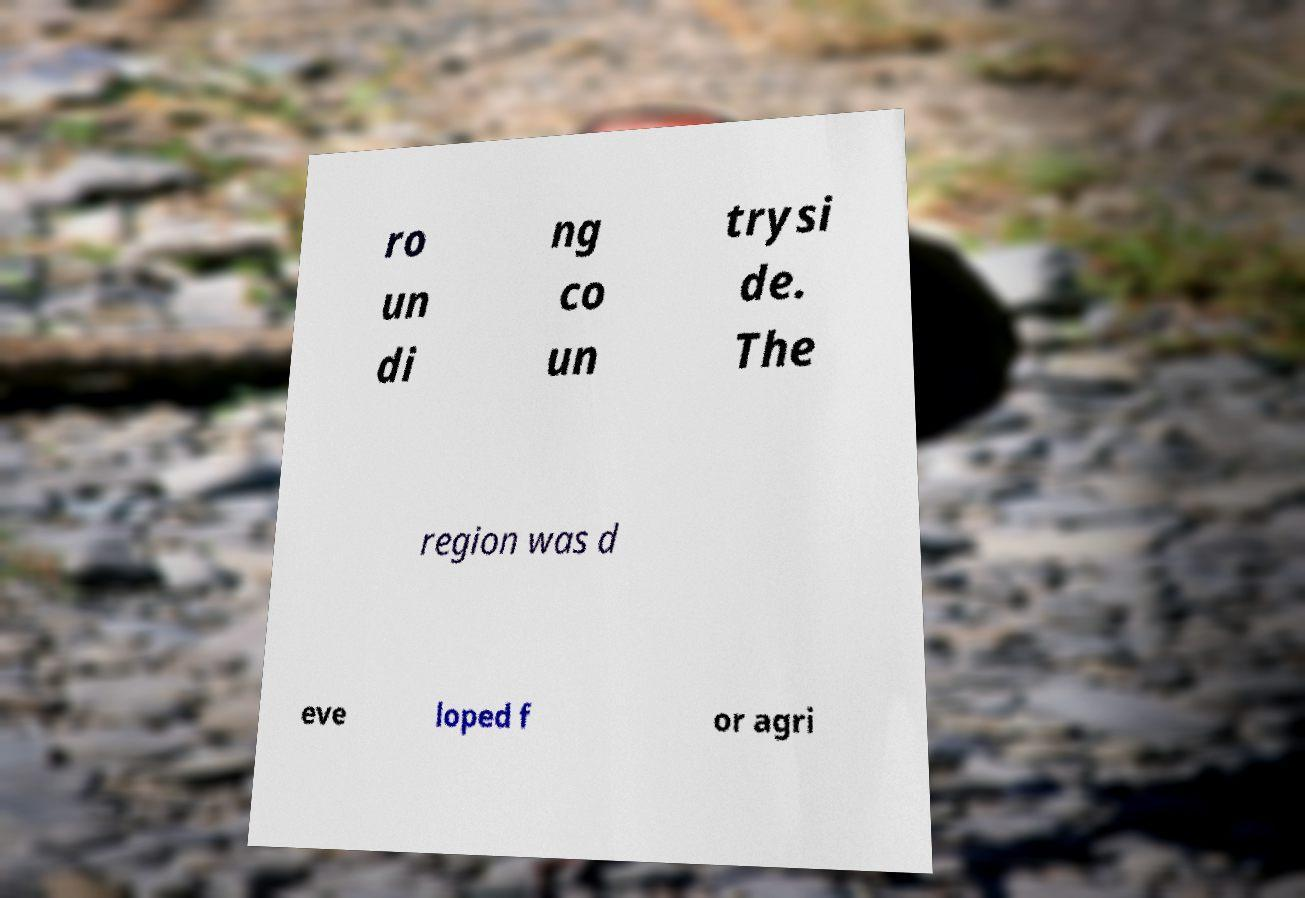Could you extract and type out the text from this image? ro un di ng co un trysi de. The region was d eve loped f or agri 